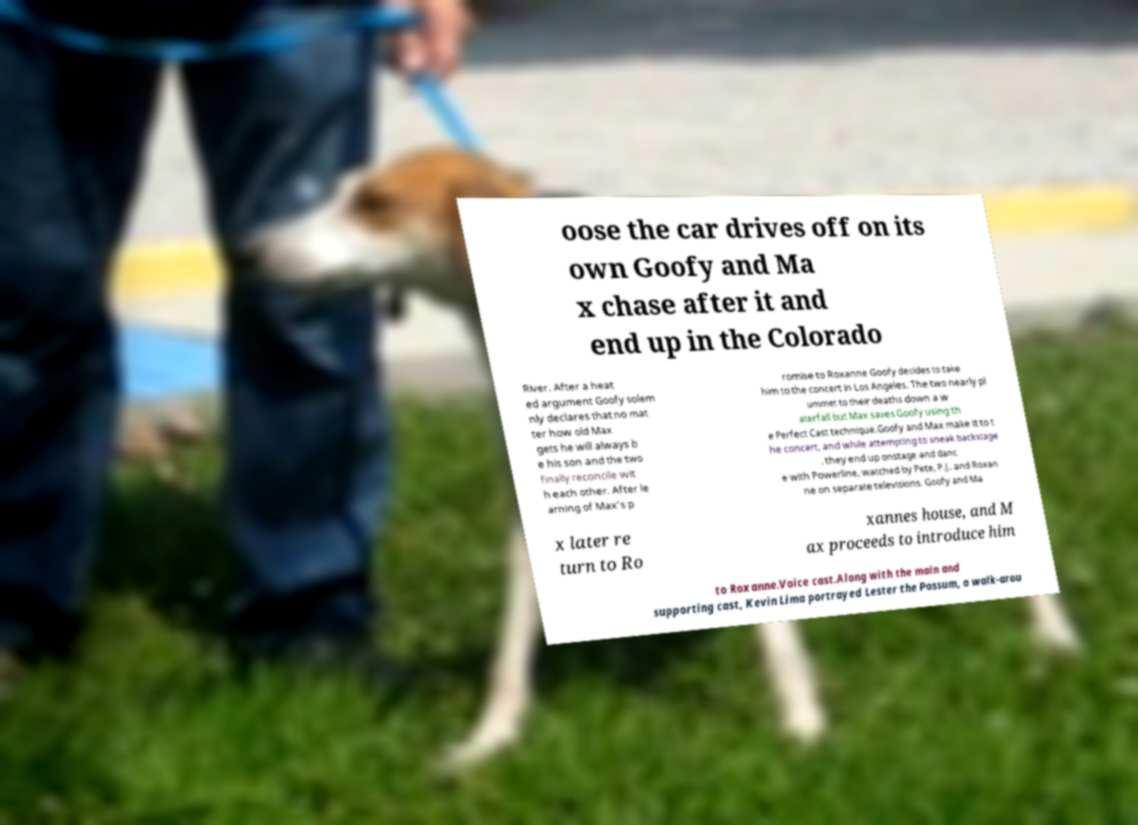Can you accurately transcribe the text from the provided image for me? oose the car drives off on its own Goofy and Ma x chase after it and end up in the Colorado River. After a heat ed argument Goofy solem nly declares that no mat ter how old Max gets he will always b e his son and the two finally reconcile wit h each other. After le arning of Max's p romise to Roxanne Goofy decides to take him to the concert in Los Angeles. The two nearly pl ummet to their deaths down a w aterfall but Max saves Goofy using th e Perfect Cast technique.Goofy and Max make it to t he concert, and while attempting to sneak backstage , they end up onstage and danc e with Powerline, watched by Pete, P.J. and Roxan ne on separate televisions. Goofy and Ma x later re turn to Ro xannes house, and M ax proceeds to introduce him to Roxanne.Voice cast.Along with the main and supporting cast, Kevin Lima portrayed Lester the Possum, a walk-arou 